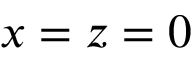Convert formula to latex. <formula><loc_0><loc_0><loc_500><loc_500>x = z = 0</formula> 